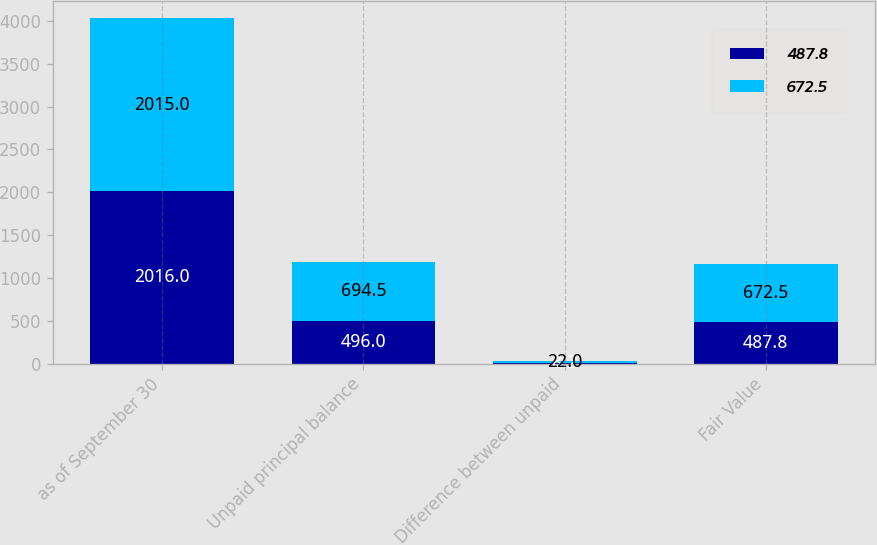Convert chart. <chart><loc_0><loc_0><loc_500><loc_500><stacked_bar_chart><ecel><fcel>as of September 30<fcel>Unpaid principal balance<fcel>Difference between unpaid<fcel>Fair Value<nl><fcel>487.8<fcel>2016<fcel>496<fcel>8.2<fcel>487.8<nl><fcel>672.5<fcel>2015<fcel>694.5<fcel>22<fcel>672.5<nl></chart> 